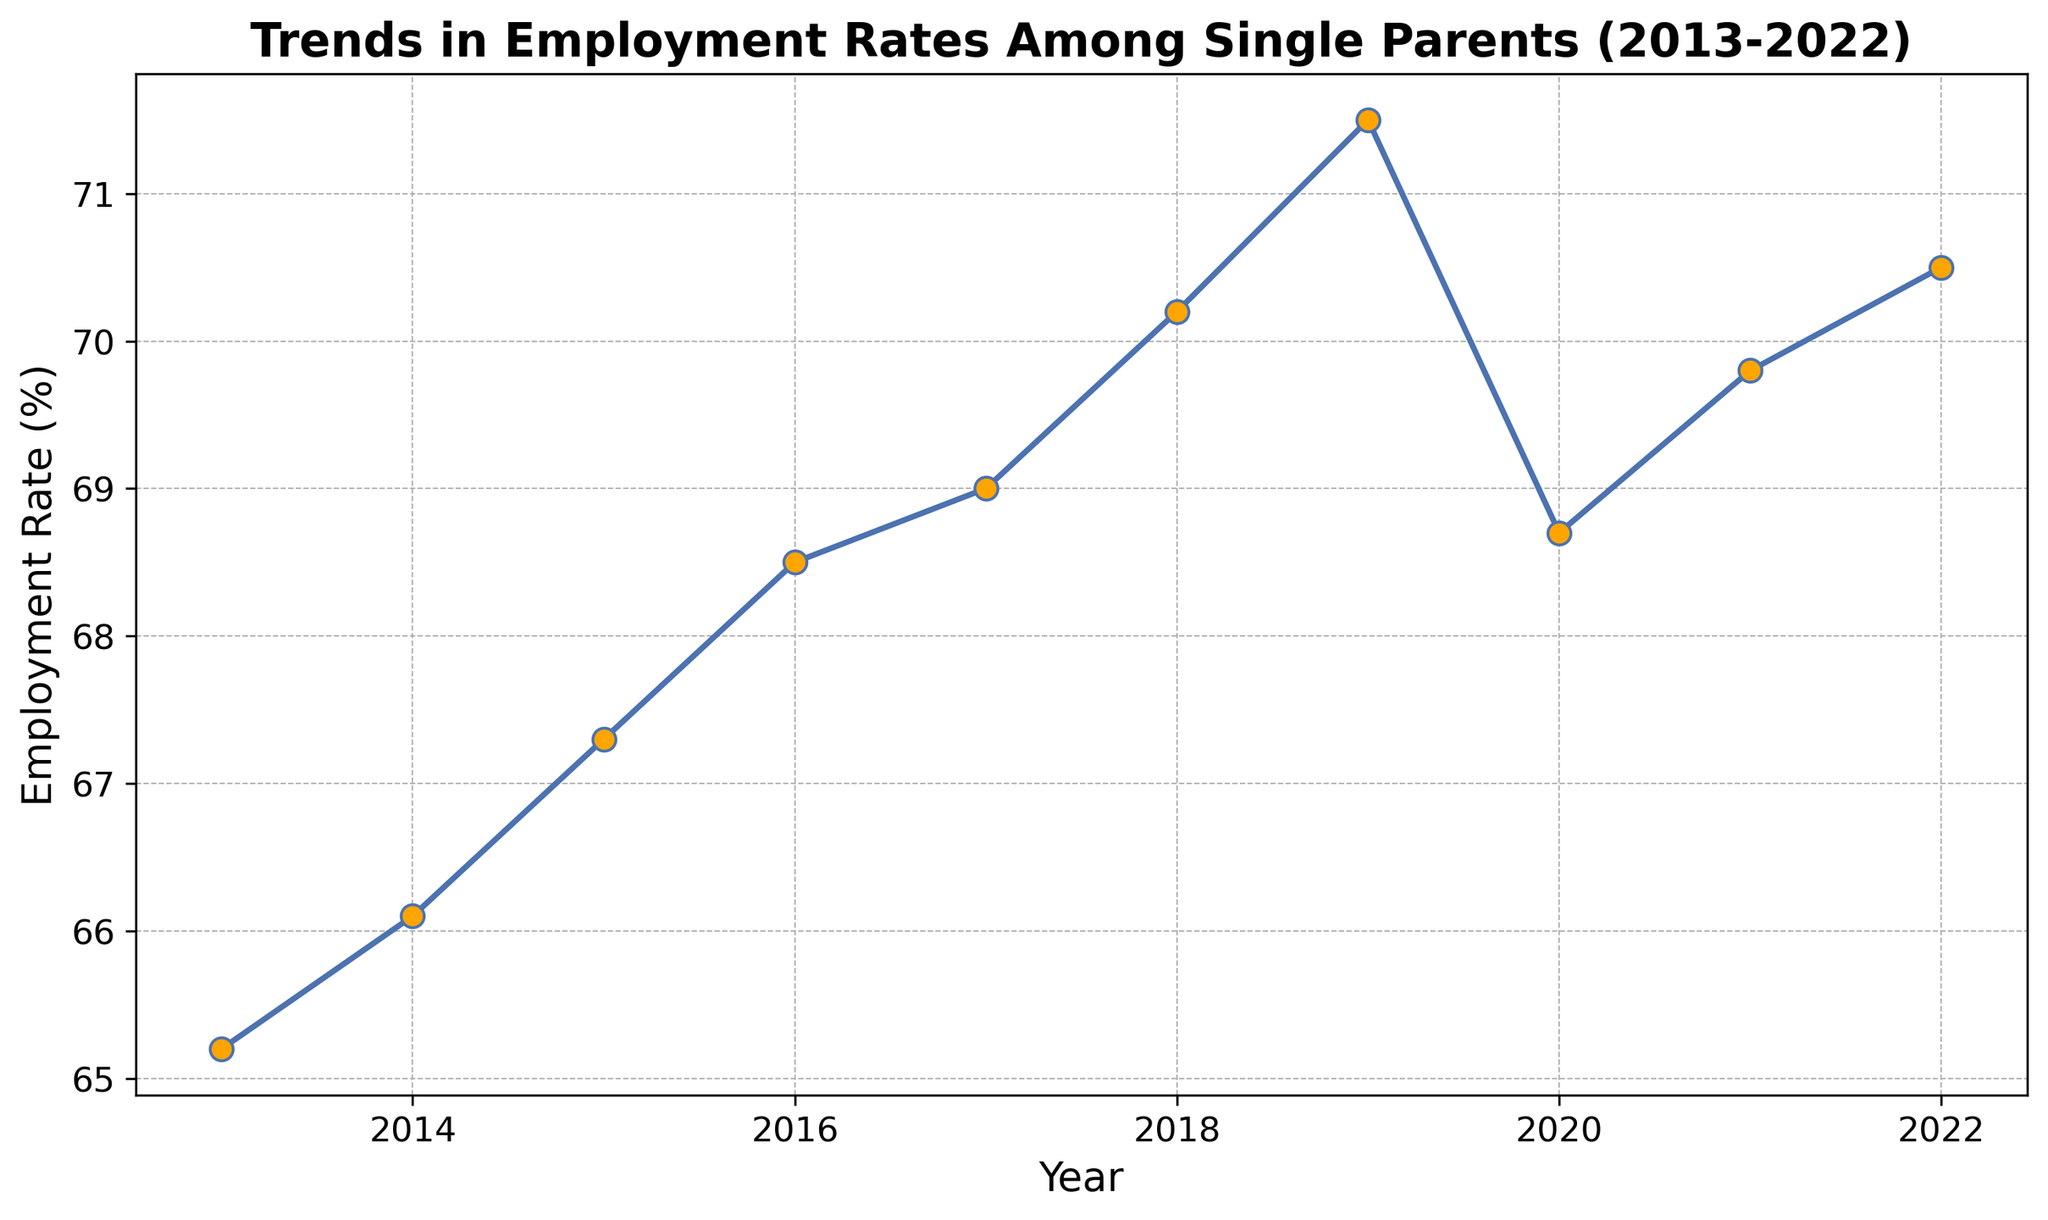What was the employment rate among single parents in 2016? Locate the data point for the year 2016 on the x-axis and observe the corresponding y-axis value, which represents the employment rate.
Answer: 68.5 In which year was the employment rate the highest? Identify the highest point on the line and then trace it down to the x-axis to find the corresponding year.
Answer: 2019 How much did the employment rate increase from 2013 to 2019? Look at the employment rates for 2013 and 2019. Subtract the 2013 rate from the 2019 rate: 71.5% - 65.2% = 6.3%.
Answer: 6.3% Which year had a lower employment rate: 2014 or 2020? Compare the employment rates for the years 2014 and 2020, and determine which is lower.
Answer: 2020 What was the average employment rate from 2018 to 2022? Extract the employment rates for the years 2018, 2019, 2020, 2021, and 2022. Average them by summing the values and dividing by the number of years: (70.2 + 71.5 + 68.7 + 69.8 + 70.5) / 5 = 70.14%.
Answer: 70.14% Was the employment rate in 2021 higher or lower than in 2015? Compare the employment rates for 2021 and 2015 to see which is higher.
Answer: Higher What is the total change in employment rate from 2013 to 2022? Subtract the employment rate of 2013 from the rate of 2022: 70.5% - 65.2% = 5.3%.
Answer: 5.3% Which year experienced a decrease in employment rate compared to its previous year? Identify where the direction of the line changes downward from one year to the next. This occurs from 2019 to 2020.
Answer: 2020 By how much did the employment rate change from 2019 to 2020? Subtract the employment rate of 2020 from the rate of 2019: 71.5% - 68.7% = 2.8%.
Answer: 2.8% How many years show an employment rate above 70%? Count the number of years where the y-axis value is greater than 70%. These years are 2018, 2019, 2021, and 2022.
Answer: 4 